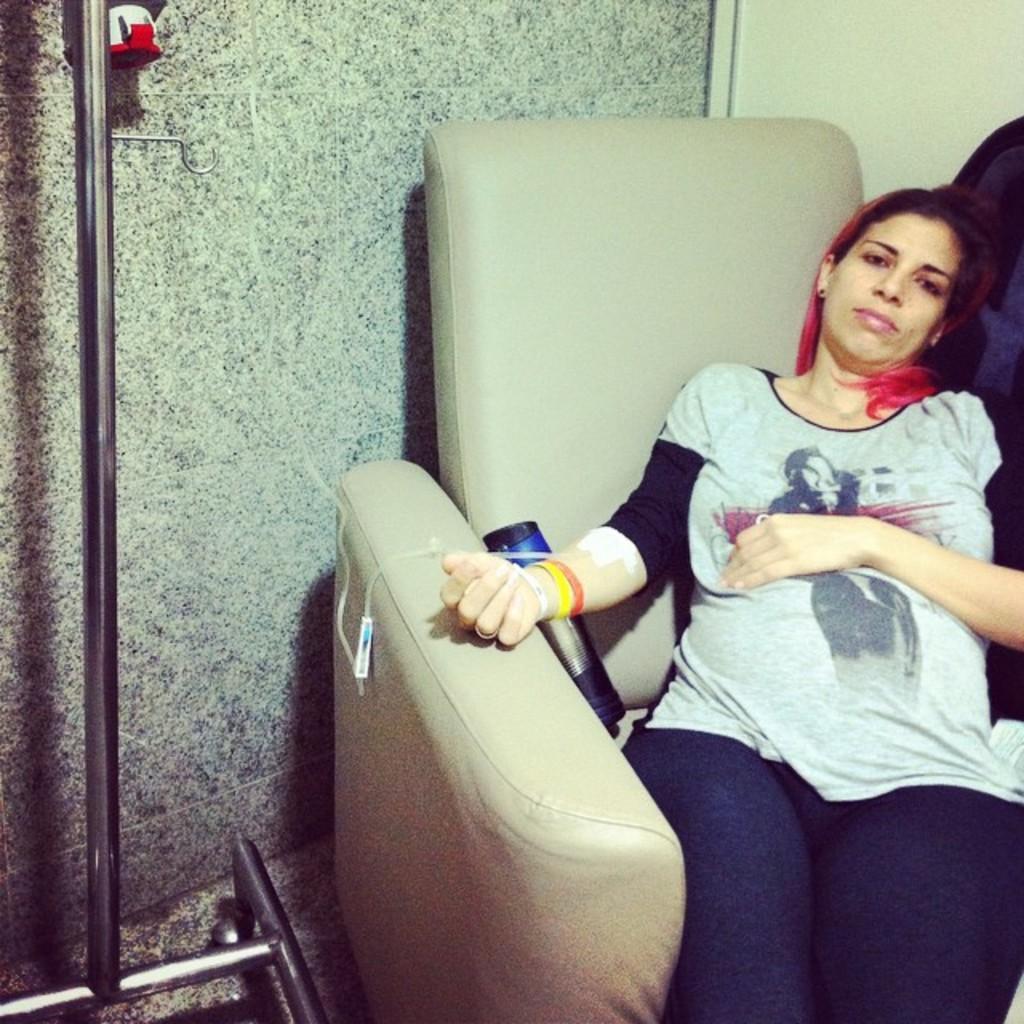Please provide a concise description of this image. In this image there is a woman sitting on the couch and there is a bottle, beside couch there is a stand. In the background there is a wall. 